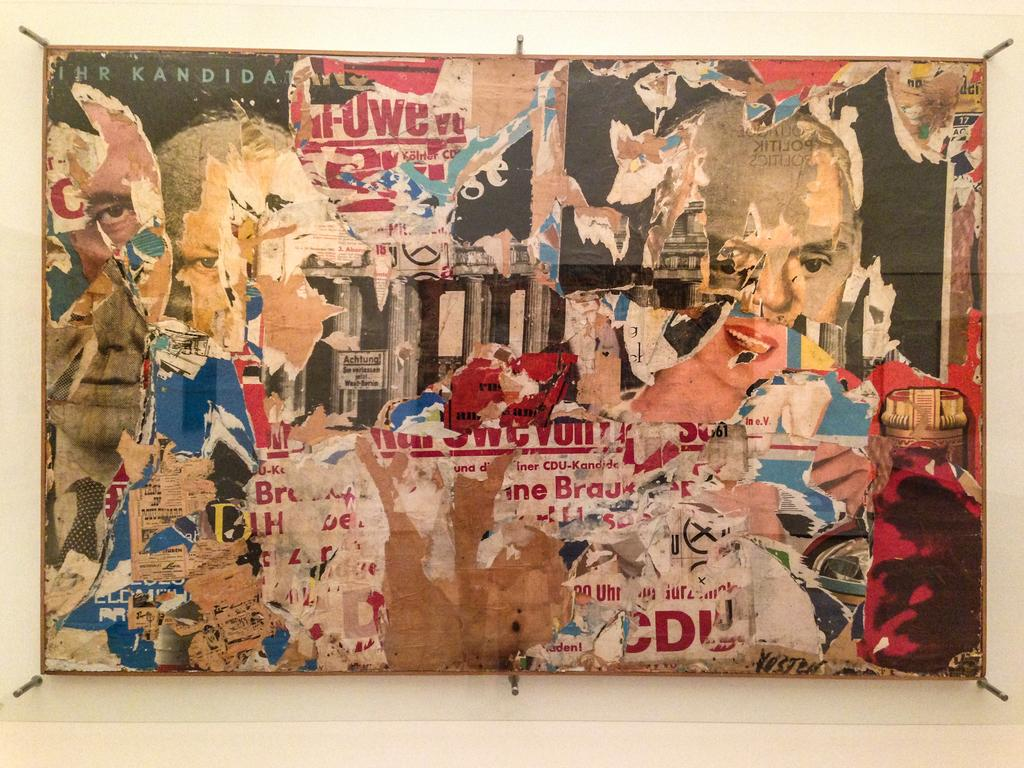What is the main subject of the image? The main subject of the image is a torn advertisement. Where is the torn advertisement located? The torn advertisement is on a board. How many balloons are attached to the torn advertisement in the image? There are no balloons present in the image. What is the amount of money mentioned on the torn advertisement? The provided facts do not mention any specific amounts or money-related information on the torn advertisement. 